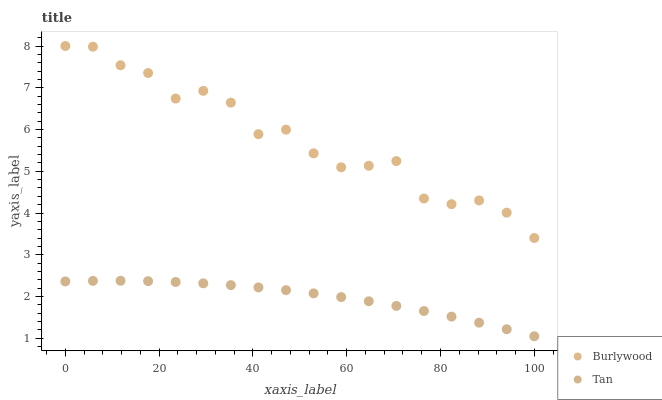Does Tan have the minimum area under the curve?
Answer yes or no. Yes. Does Burlywood have the maximum area under the curve?
Answer yes or no. Yes. Does Tan have the maximum area under the curve?
Answer yes or no. No. Is Tan the smoothest?
Answer yes or no. Yes. Is Burlywood the roughest?
Answer yes or no. Yes. Is Tan the roughest?
Answer yes or no. No. Does Tan have the lowest value?
Answer yes or no. Yes. Does Burlywood have the highest value?
Answer yes or no. Yes. Does Tan have the highest value?
Answer yes or no. No. Is Tan less than Burlywood?
Answer yes or no. Yes. Is Burlywood greater than Tan?
Answer yes or no. Yes. Does Tan intersect Burlywood?
Answer yes or no. No. 